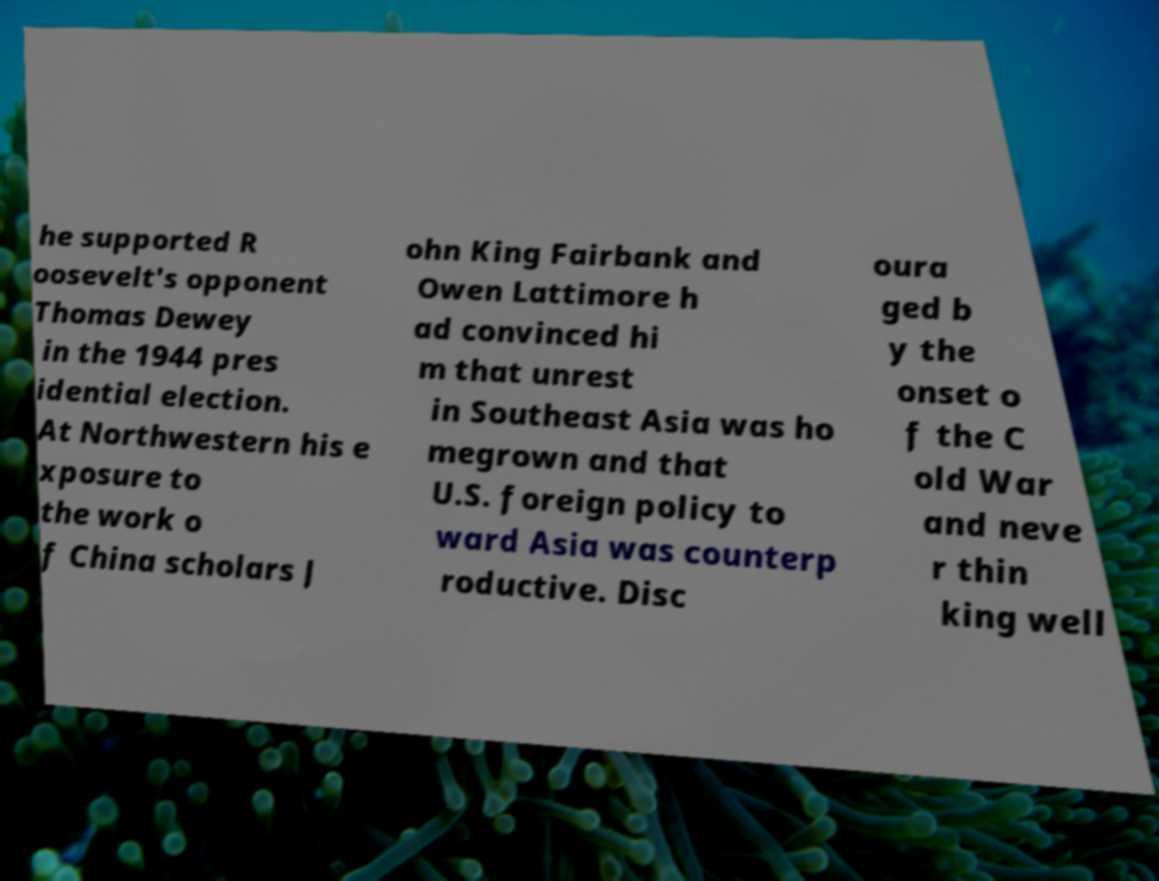Could you assist in decoding the text presented in this image and type it out clearly? he supported R oosevelt's opponent Thomas Dewey in the 1944 pres idential election. At Northwestern his e xposure to the work o f China scholars J ohn King Fairbank and Owen Lattimore h ad convinced hi m that unrest in Southeast Asia was ho megrown and that U.S. foreign policy to ward Asia was counterp roductive. Disc oura ged b y the onset o f the C old War and neve r thin king well 